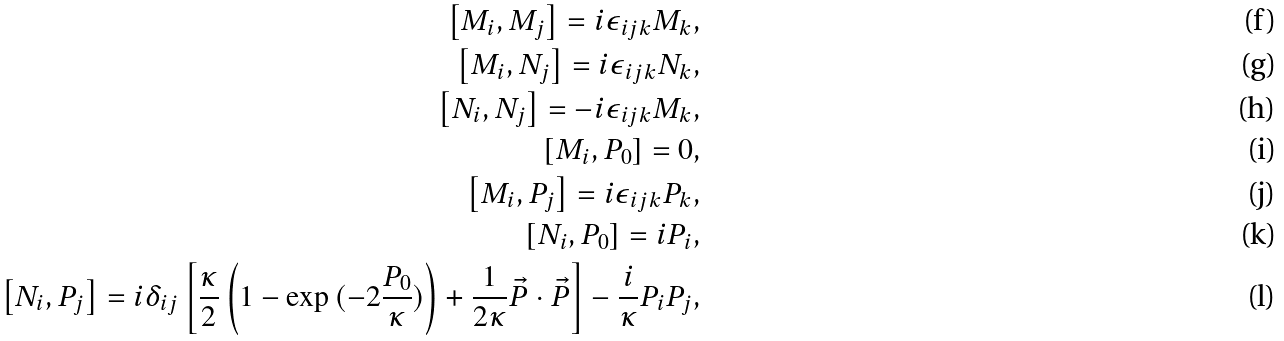Convert formula to latex. <formula><loc_0><loc_0><loc_500><loc_500>\left [ M _ { i } , M _ { j } \right ] = i \epsilon _ { i j k } M _ { k } , \\ \left [ M _ { i } , N _ { j } \right ] = i \epsilon _ { i j k } N _ { k } , \\ \left [ N _ { i } , N _ { j } \right ] = - i \epsilon _ { i j k } M _ { k } , \\ \left [ M _ { i } , P _ { 0 } \right ] = 0 , \\ \left [ M _ { i } , P _ { j } \right ] = i \epsilon _ { i j k } P _ { k } , \\ \left [ N _ { i } , P _ { 0 } \right ] = i P _ { i } , \\ \left [ N _ { i } , P _ { j } \right ] = i \delta _ { i j } \left [ \frac { \kappa } { 2 } \left ( 1 - \exp { ( - 2 \frac { P _ { 0 } } { \kappa } ) } \right ) + \frac { 1 } { 2 \kappa } \vec { P } \cdot \vec { P } \right ] - \frac { i } { \kappa } P _ { i } P _ { j } ,</formula> 